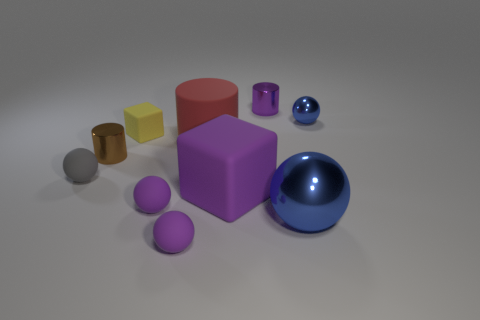Considering the lighting and shadows, what can you infer about the light source in this image? Judging by the shadows and the highlights on the objects, there seems to be a single, diffused light source positioned above and slightly to the right of the scene. The soft edges of the shadows suggest that the light source is not overly harsh, which helps in creating a gentle illumination throughout the composition. 